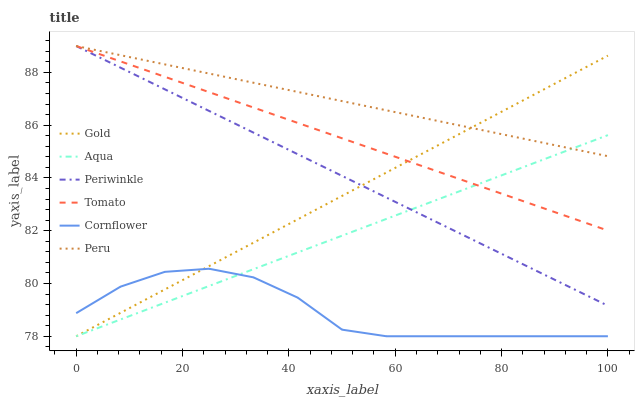Does Cornflower have the minimum area under the curve?
Answer yes or no. Yes. Does Peru have the maximum area under the curve?
Answer yes or no. Yes. Does Gold have the minimum area under the curve?
Answer yes or no. No. Does Gold have the maximum area under the curve?
Answer yes or no. No. Is Tomato the smoothest?
Answer yes or no. Yes. Is Cornflower the roughest?
Answer yes or no. Yes. Is Gold the smoothest?
Answer yes or no. No. Is Gold the roughest?
Answer yes or no. No. Does Cornflower have the lowest value?
Answer yes or no. Yes. Does Periwinkle have the lowest value?
Answer yes or no. No. Does Peru have the highest value?
Answer yes or no. Yes. Does Gold have the highest value?
Answer yes or no. No. Is Cornflower less than Peru?
Answer yes or no. Yes. Is Peru greater than Cornflower?
Answer yes or no. Yes. Does Cornflower intersect Aqua?
Answer yes or no. Yes. Is Cornflower less than Aqua?
Answer yes or no. No. Is Cornflower greater than Aqua?
Answer yes or no. No. Does Cornflower intersect Peru?
Answer yes or no. No. 